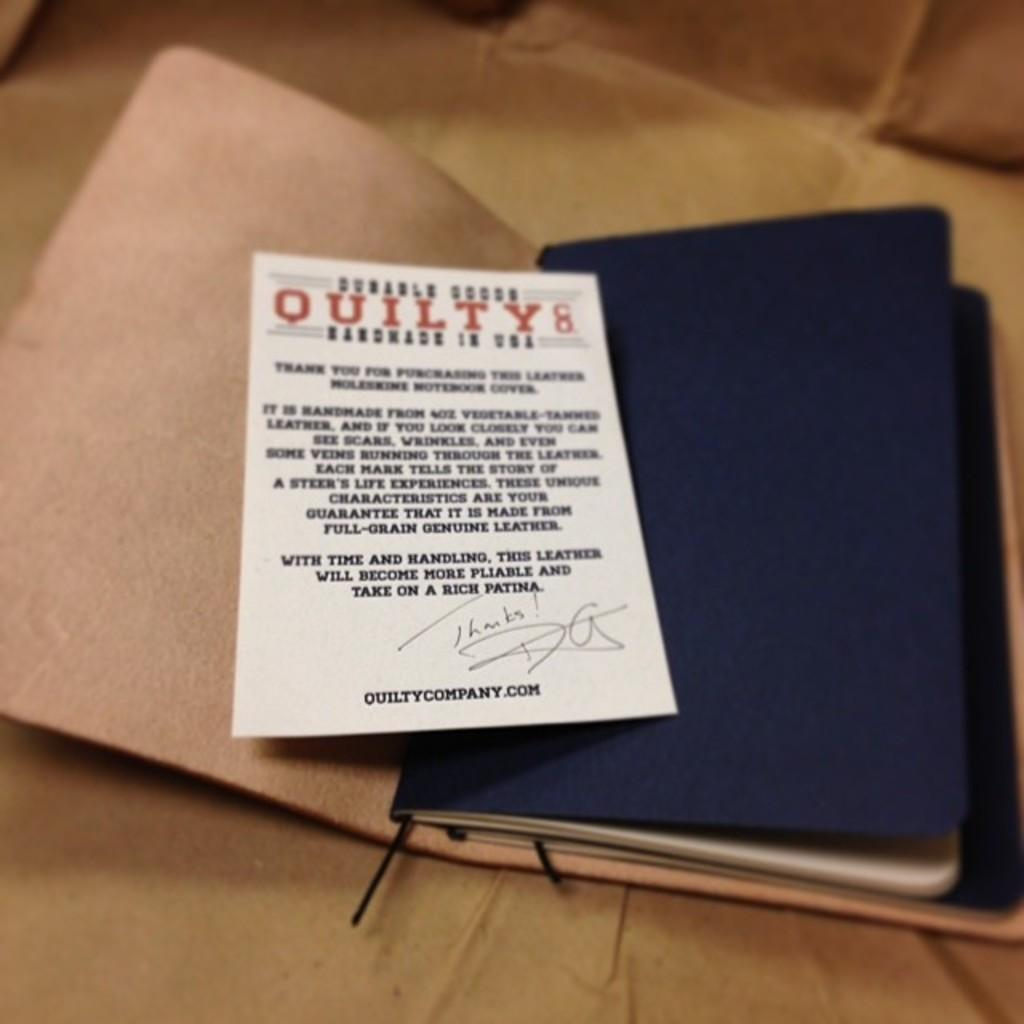<image>
Offer a succinct explanation of the picture presented. A white card is on top of a black book and lists a website for the quilt company. 